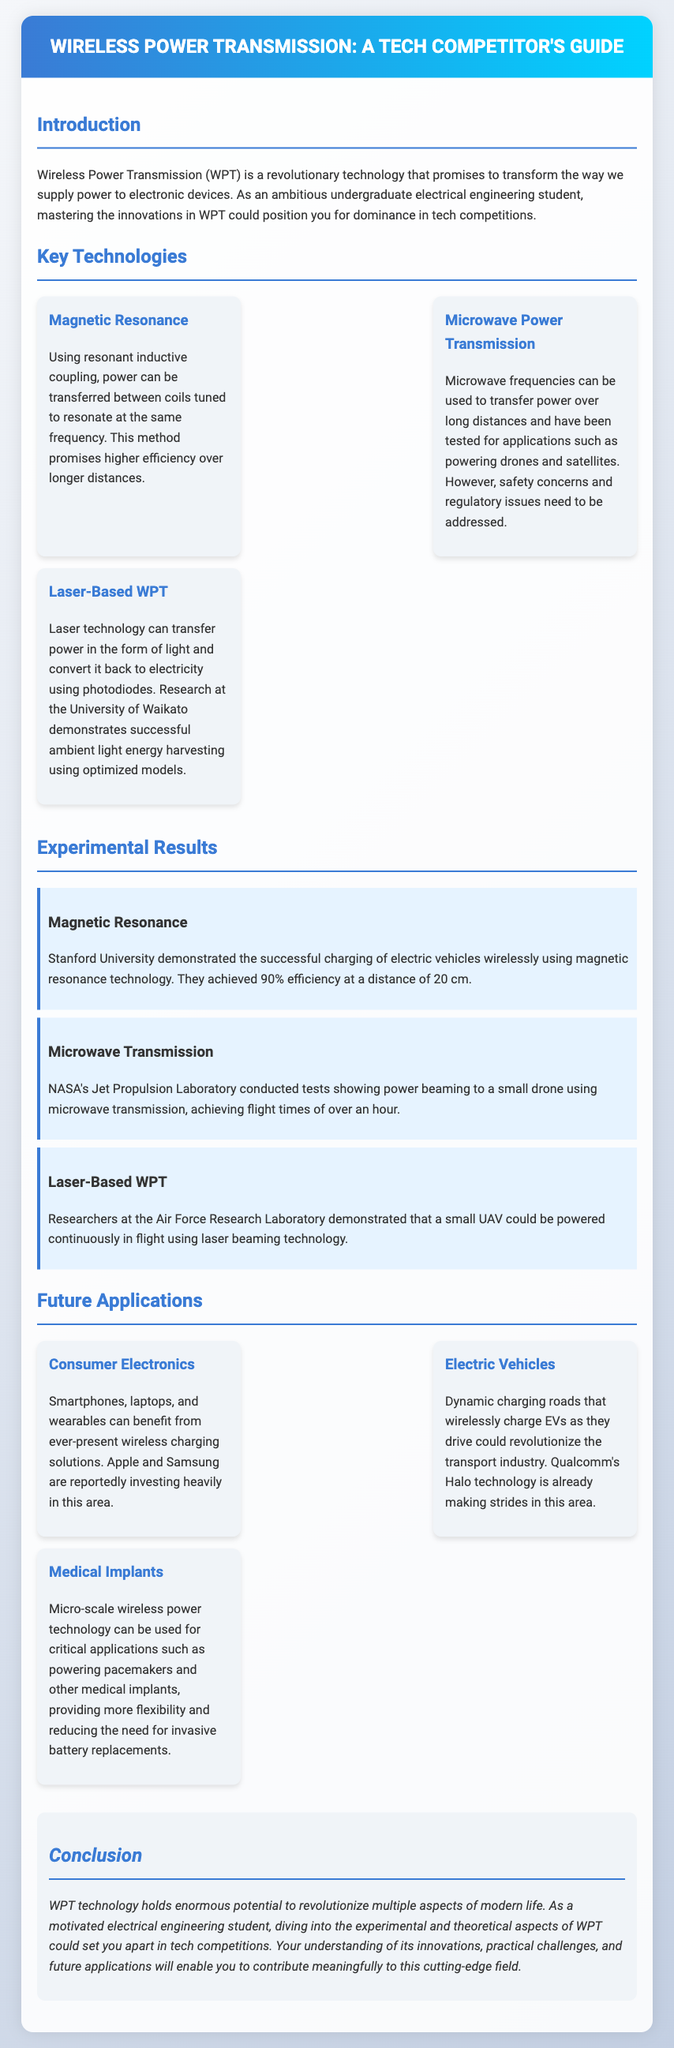What is Wireless Power Transmission? Wireless Power Transmission is a revolutionary technology that promises to transform the way we supply power to electronic devices.
Answer: Wireless Power Transmission What is the efficiency achieved by Stanford University using magnetic resonance? Stanford University achieved 90% efficiency at a distance of 20 cm using magnetic resonance technology.
Answer: 90% Which technology can transfer power over long distances and has been tested for powering drones? Microwave frequencies can be used to transfer power over long distances for applications such as powering drones.
Answer: Microwave Power Transmission What is one application of micro-scale wireless power technology mentioned in the document? Micro-scale wireless power technology can be used for powering pacemakers and other medical implants.
Answer: Medical Implants Who conducted experiments demonstrating power beaming to a small drone? NASA's Jet Propulsion Laboratory conducted tests showing power beaming to a small drone.
Answer: NASA's Jet Propulsion Laboratory 